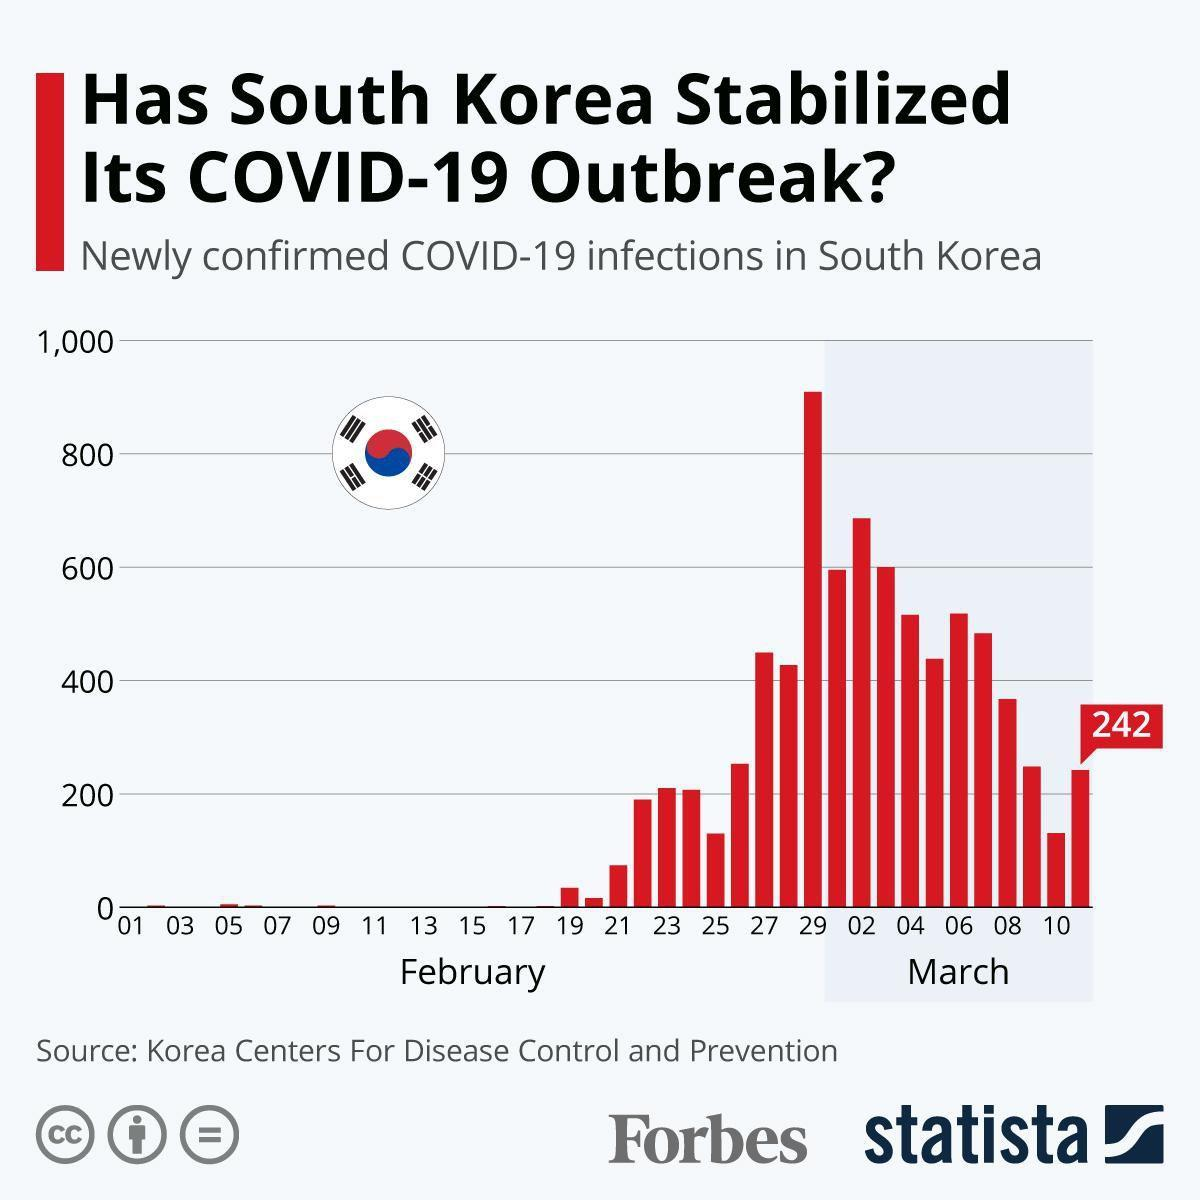When did South Korea reported more than 800 newly confirmed COVID-19 cases?
Answer the question with a short phrase. February 29 When did South Korea reported more than 600 newly confirmed COVID-19 cases? March 02 What is the number of newly confirmed COVID-19 cases in South Korea on March 11? 242 